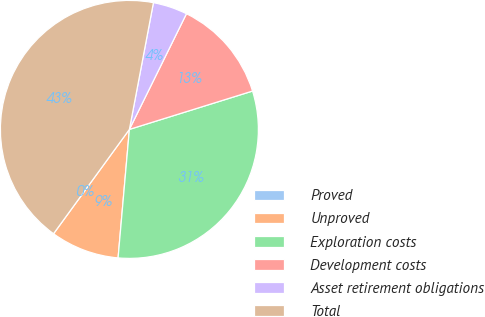<chart> <loc_0><loc_0><loc_500><loc_500><pie_chart><fcel>Proved<fcel>Unproved<fcel>Exploration costs<fcel>Development costs<fcel>Asset retirement obligations<fcel>Total<nl><fcel>0.01%<fcel>8.6%<fcel>31.2%<fcel>12.9%<fcel>4.31%<fcel>42.97%<nl></chart> 